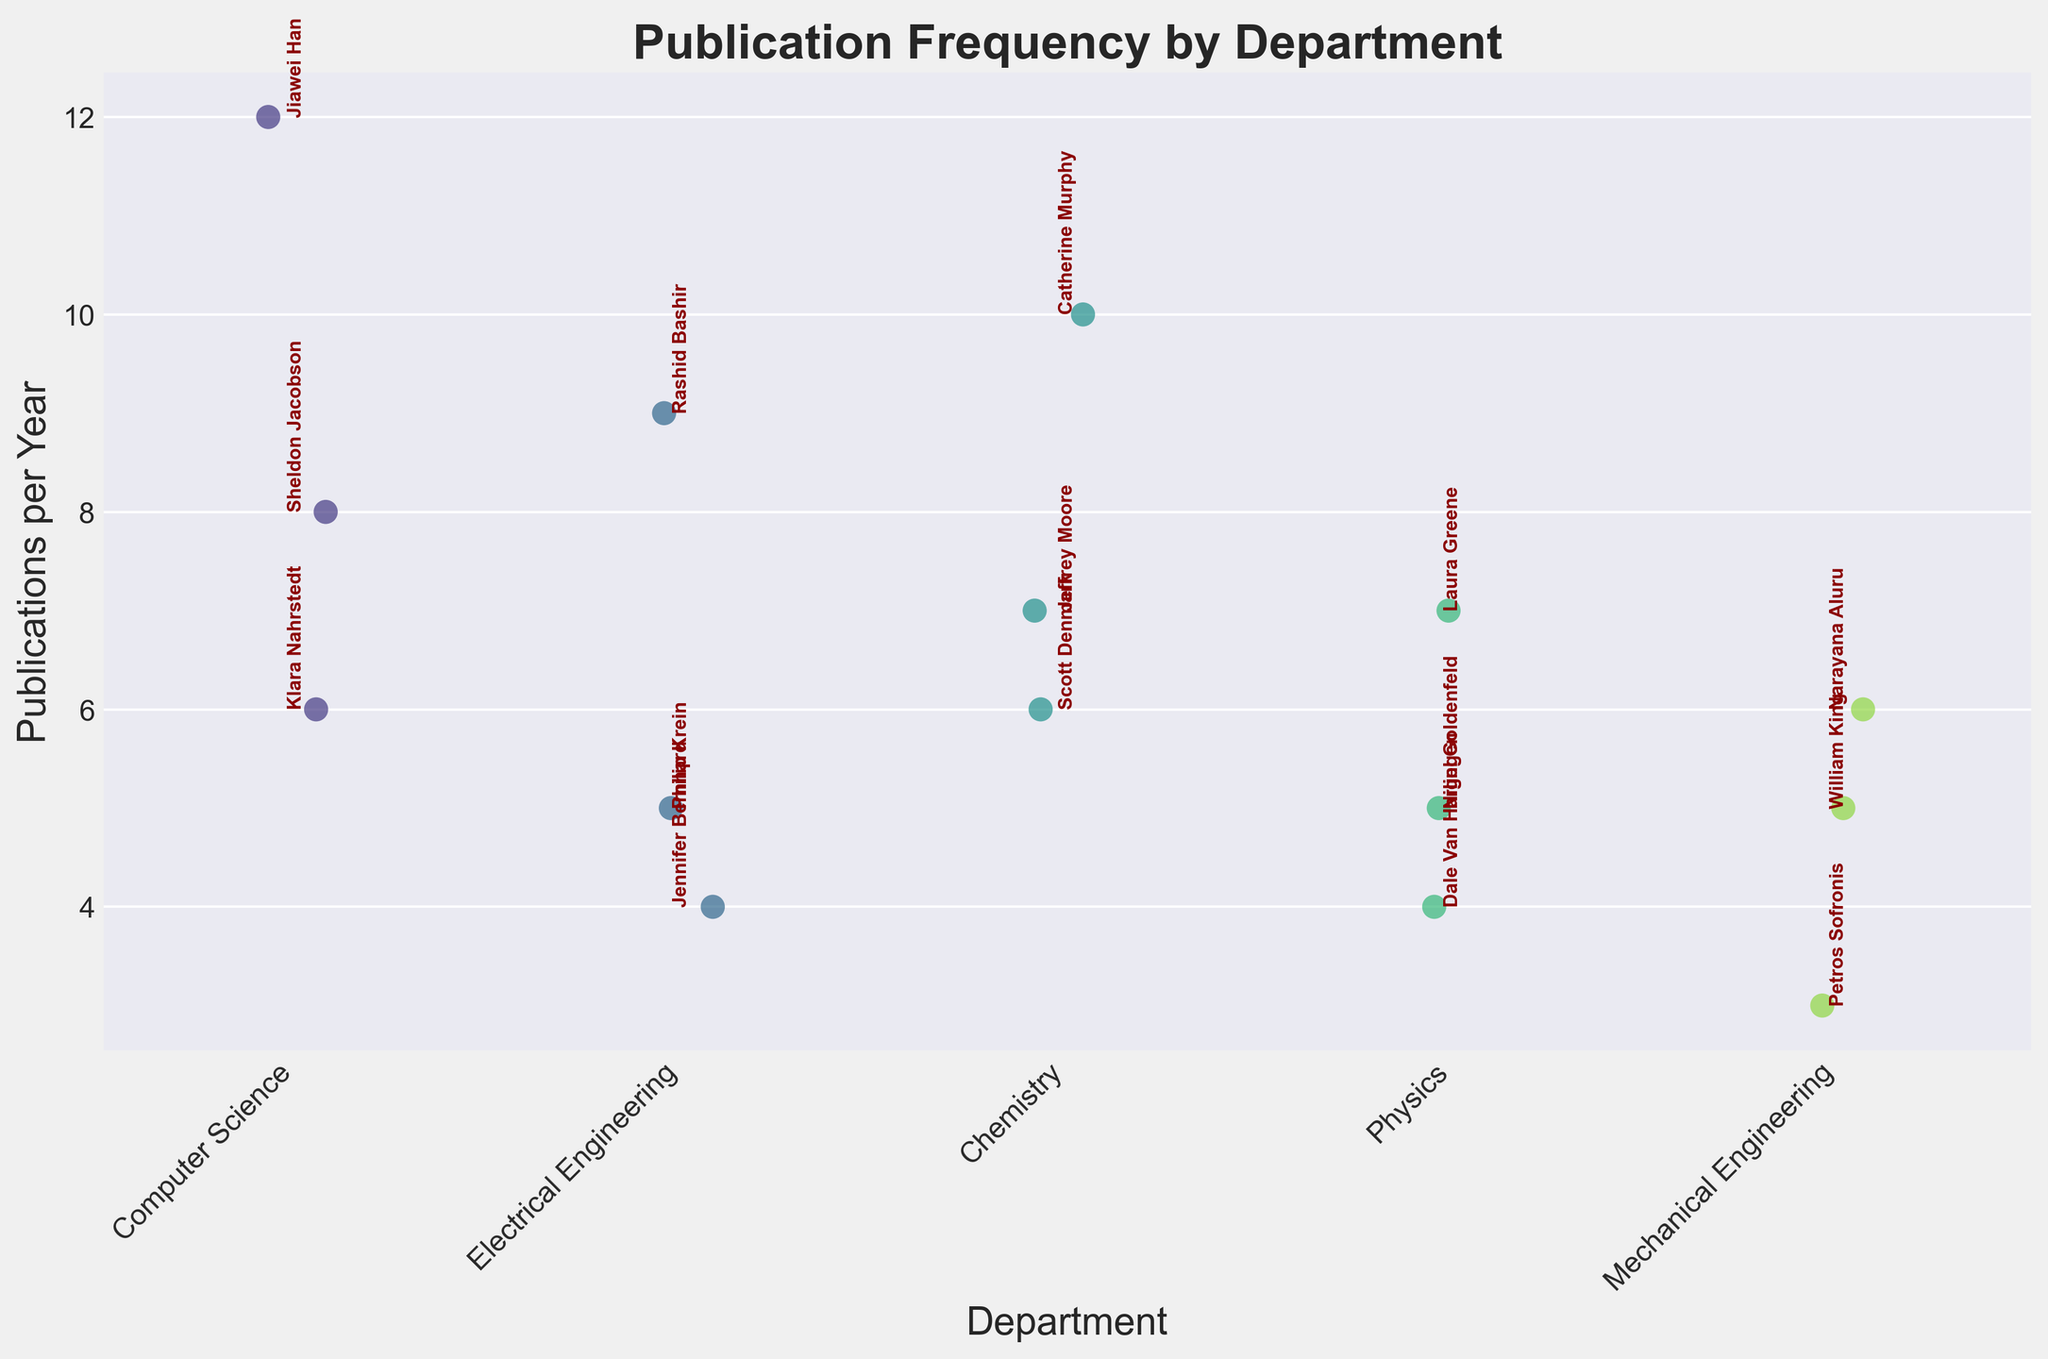What is the title of the Strip Plot? The title of a plot is usually displayed at the top and provides a summary of what the plot represents. Here, it states 'Publication Frequency by Department'.
Answer: Publication Frequency by Department Which department has the researcher with the highest publication frequency? By examining the y-axis (Publications per Year) and looking for the highest data point value, we see that Jiawei Han from Computer Science has the highest publication frequency with 12 publications per year.
Answer: Computer Science How many departments are included in the plot? Looking at the x-axis, each department is listed as a separate category. There are 5 distinct departments: Computer Science, Electrical Engineering, Chemistry, Physics, and Mechanical Engineering.
Answer: 5 What is the range of publication frequencies in the Chemistry department? The publication frequencies of researchers in Chemistry can be seen by identifying the points above the Chemistry label on the x-axis. The minimum is 6 (Scott Denmark) and the maximum is 10 (Catherine Murphy). The range is calculated as the maximum minus the minimum: 10 - 6 = 4.
Answer: 4 Which researcher in Electrical Engineering has the highest publication frequency, and what is it? Looking at the data points above the Electrical Engineering label on the x-axis, the researcher with the highest dot (highest y-value) is Rashid Bashir with 9 publications per year.
Answer: Rashid Bashir, 9 How does the average publication frequency of researchers in Computer Science compare to Mechanical Engineering? To calculate the averages, we sum the publication frequencies for each department and divide by the number of researchers. In Computer Science: (8 + 6 + 12) / 3 = 8.67. In Mechanical Engineering: (3 + 6 + 5) / 3 = 4.67. Comparing these values, Computer Science has a higher average publication frequency.
Answer: Computer Science, higher What is the median publication frequency among all researchers in the Physics department? Sorting the publication frequencies in Physics (5, 7, 4) results in: 4, 5, 7. The median (middle value) is 5.
Answer: 5 Which department has the least variation in publication frequency among its researchers? Variation can be understood by looking at the spread of data points. Mechanical Engineering has the least spread as evidenced by its closely grouped publication numbers (3, 6, 5).
Answer: Mechanical Engineering How many researchers in the plot have a publication frequency of at least 7 publications per year? By counting the data points at or above 7 on the y-axis, the researchers are: Sheldon Jacobson, Jiawei Han, Rashid Bashir, Catherine Murphy, Jeffrey Moore, and Laura Greene. This totals to 6.
Answer: 6 What is the average publication frequency of researchers in Electrical Engineering? Summing the publication frequencies and dividing by the number of researchers: (5 + 9 + 4) / 3 = 6.
Answer: 6 